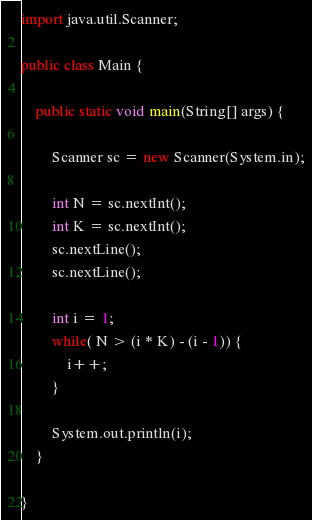<code> <loc_0><loc_0><loc_500><loc_500><_Java_>import java.util.Scanner;

public class Main {

	public static void main(String[] args) {

		Scanner sc = new Scanner(System.in);

		int N = sc.nextInt();
		int K = sc.nextInt();
		sc.nextLine();
		sc.nextLine();

		int i = 1;
		while( N > (i * K) - (i - 1)) {
			i++;
		}

		System.out.println(i);
	}

}</code> 